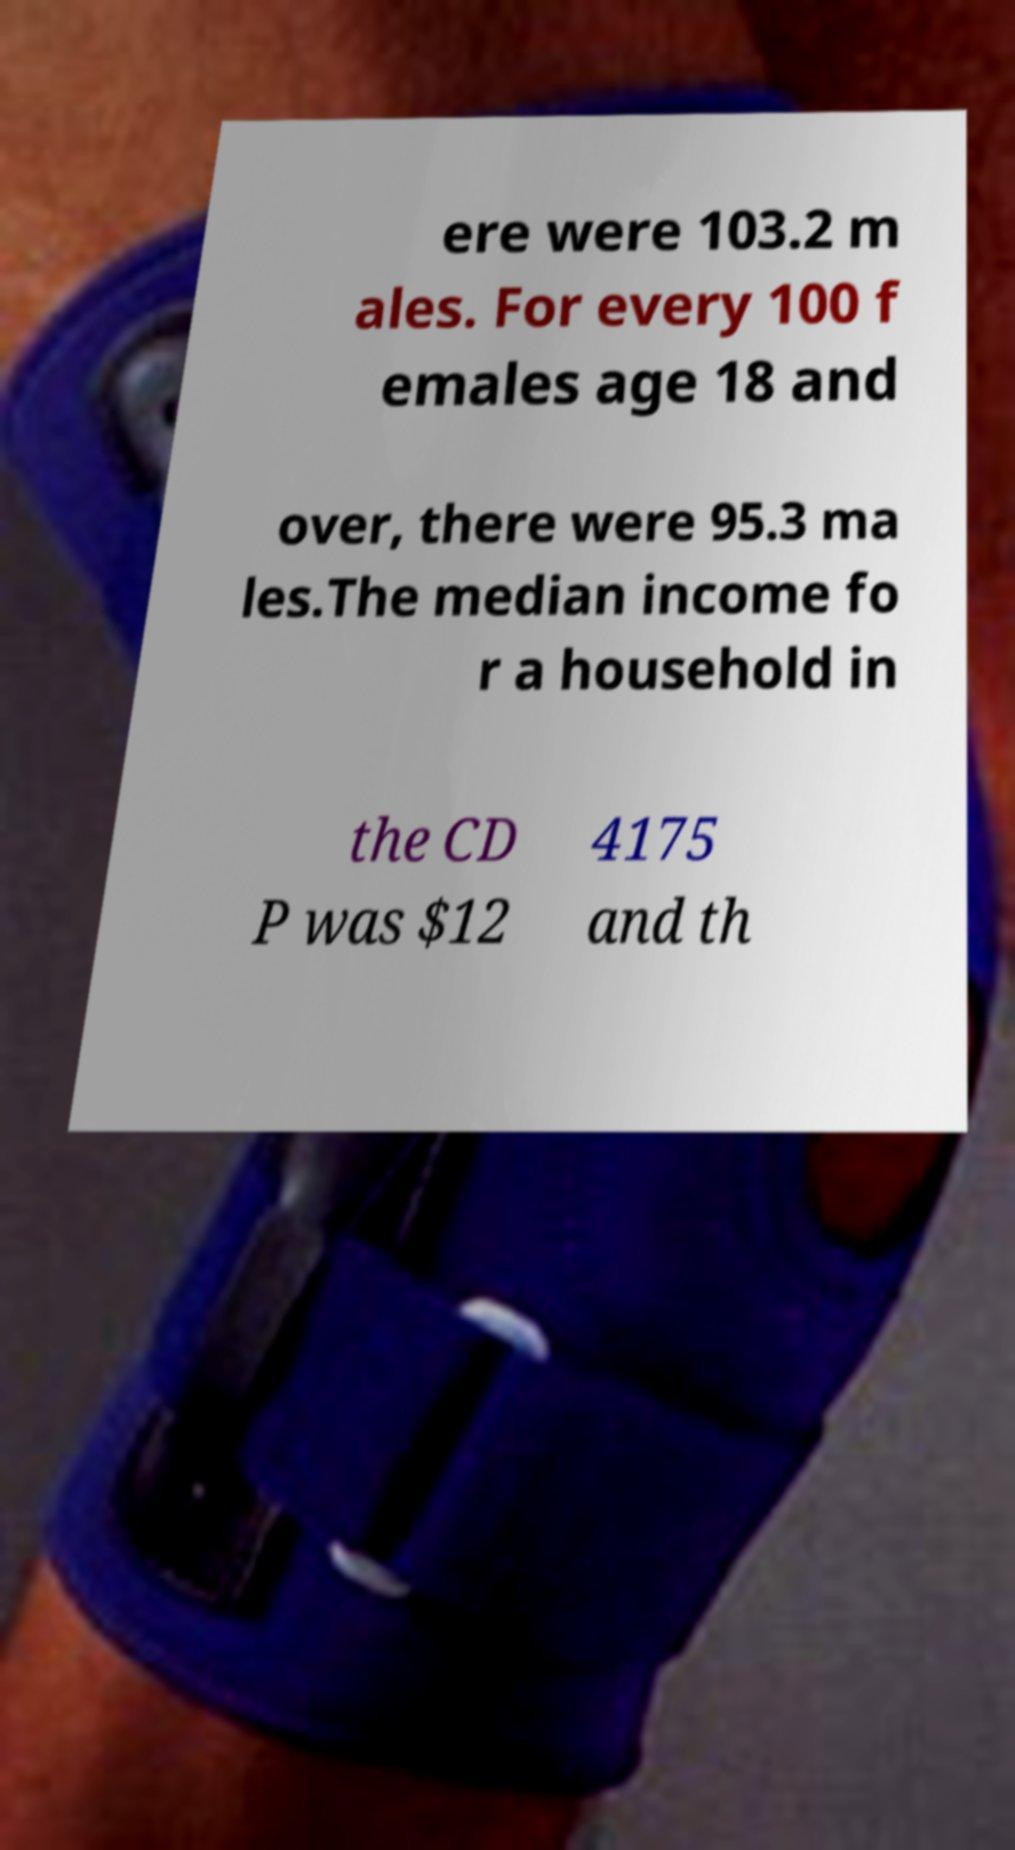Could you extract and type out the text from this image? ere were 103.2 m ales. For every 100 f emales age 18 and over, there were 95.3 ma les.The median income fo r a household in the CD P was $12 4175 and th 